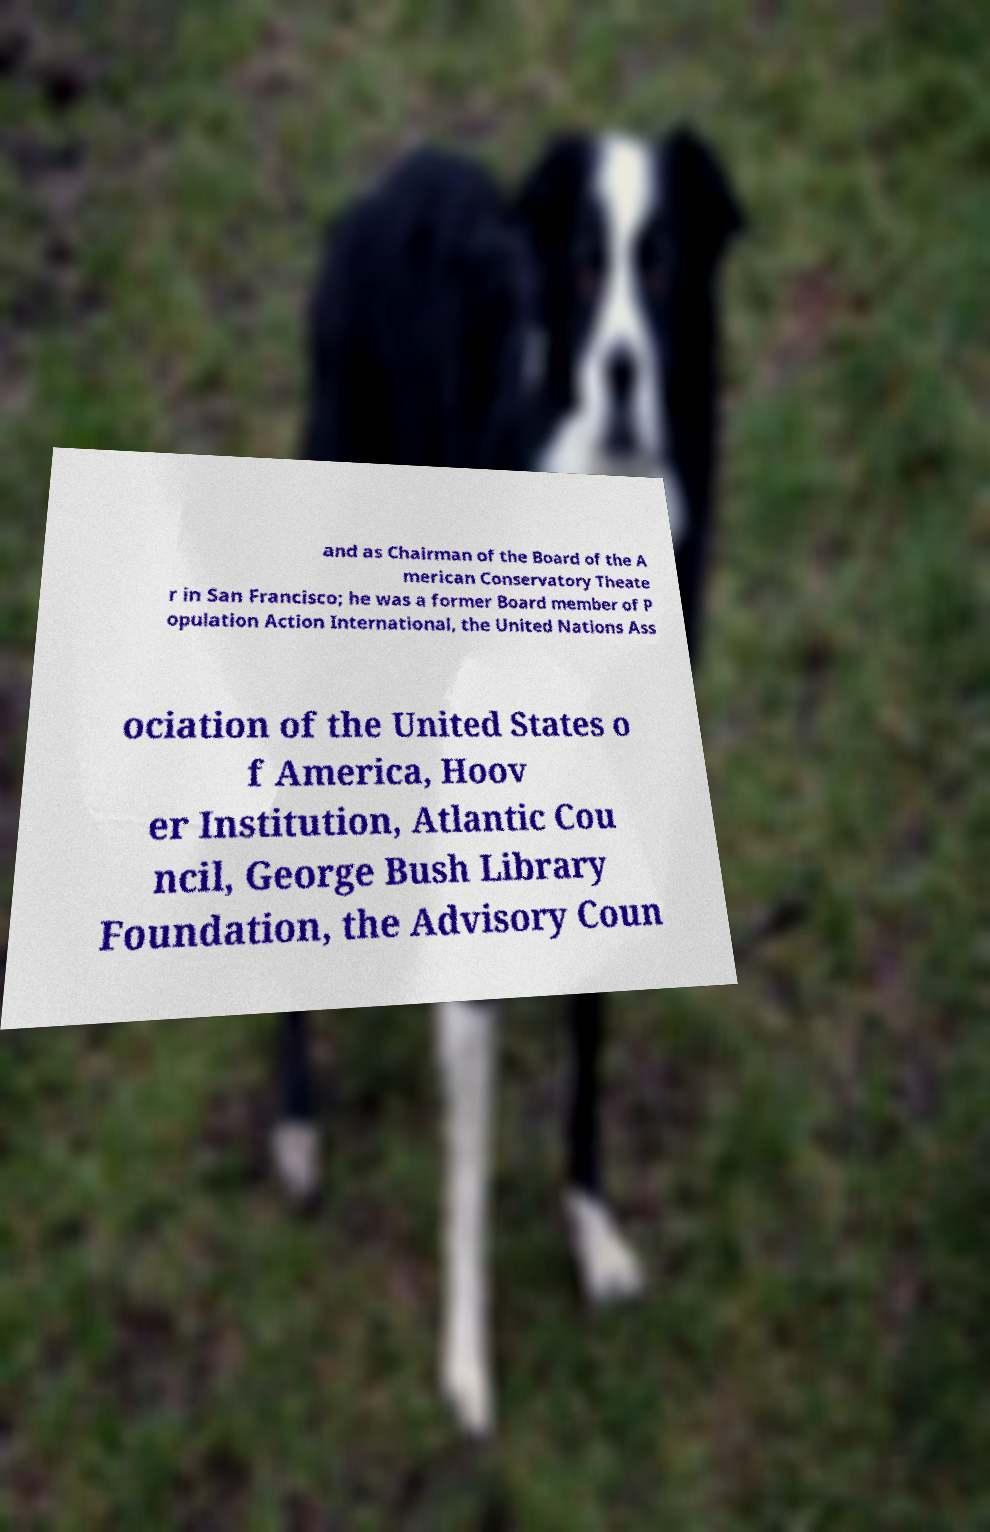Please read and relay the text visible in this image. What does it say? and as Chairman of the Board of the A merican Conservatory Theate r in San Francisco; he was a former Board member of P opulation Action International, the United Nations Ass ociation of the United States o f America, Hoov er Institution, Atlantic Cou ncil, George Bush Library Foundation, the Advisory Coun 